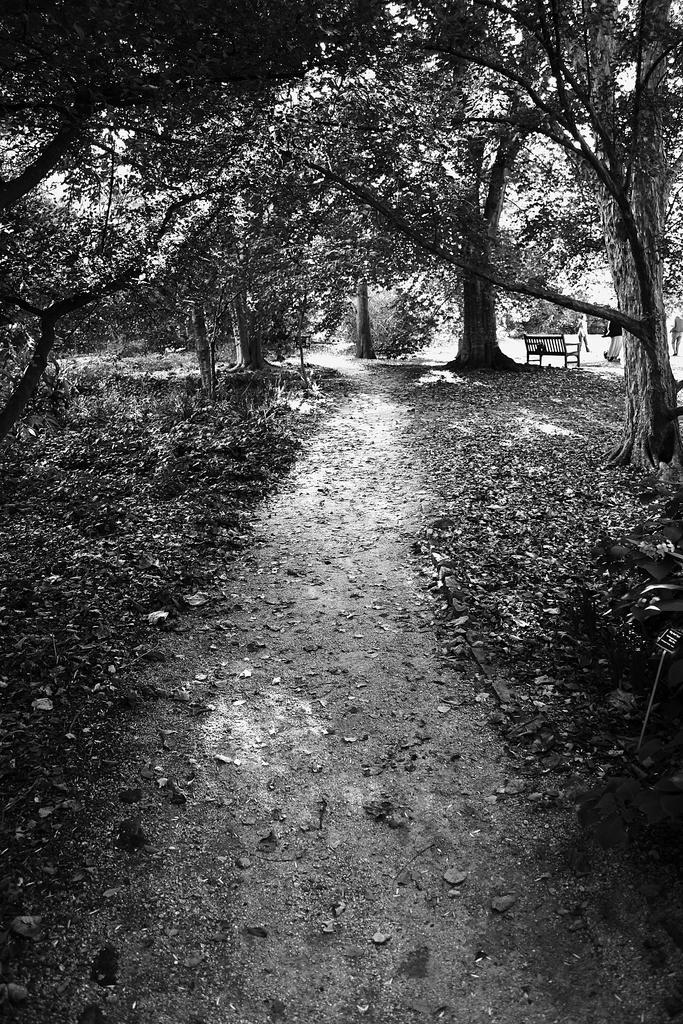Please provide a concise description of this image. In this picture we can see a black and white image and we can see some trees and dry leaves on the ground and there is a bench in the background. 